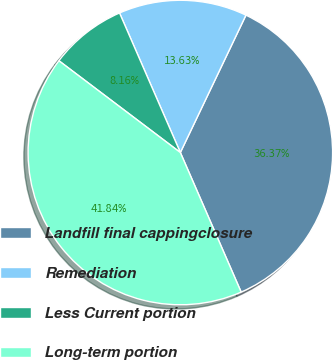Convert chart to OTSL. <chart><loc_0><loc_0><loc_500><loc_500><pie_chart><fcel>Landfill final cappingclosure<fcel>Remediation<fcel>Less Current portion<fcel>Long-term portion<nl><fcel>36.37%<fcel>13.63%<fcel>8.16%<fcel>41.84%<nl></chart> 